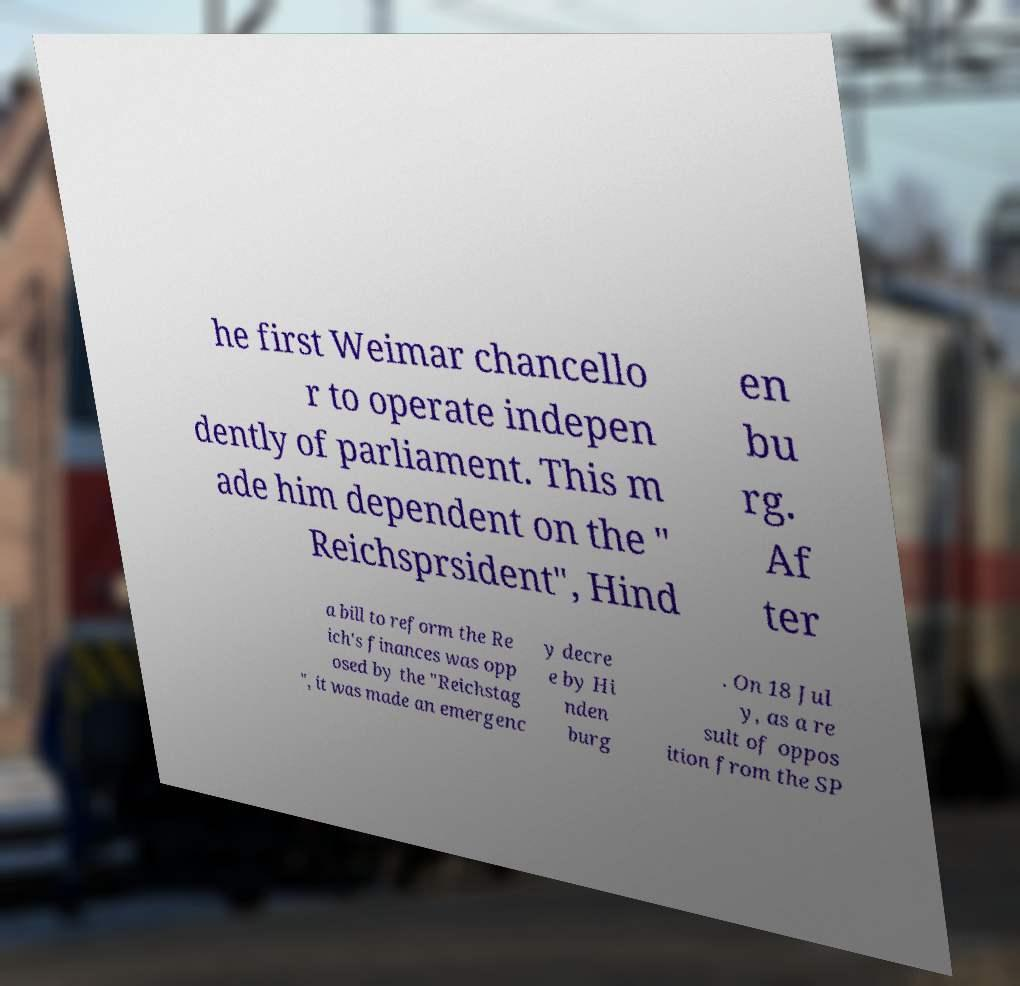What messages or text are displayed in this image? I need them in a readable, typed format. he first Weimar chancello r to operate indepen dently of parliament. This m ade him dependent on the " Reichsprsident", Hind en bu rg. Af ter a bill to reform the Re ich's finances was opp osed by the "Reichstag ", it was made an emergenc y decre e by Hi nden burg . On 18 Jul y, as a re sult of oppos ition from the SP 